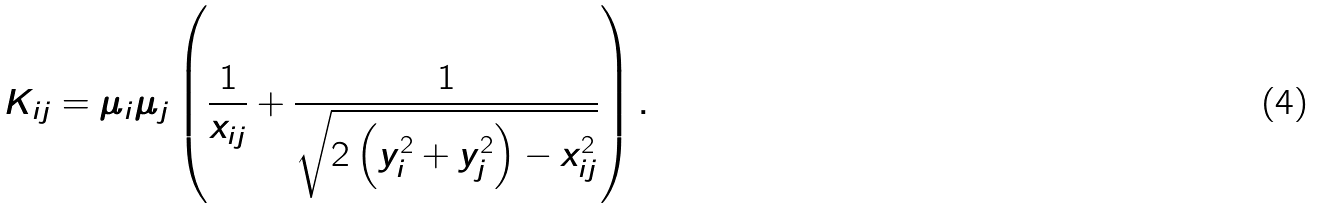<formula> <loc_0><loc_0><loc_500><loc_500>K _ { i j } = \mu _ { i } \mu _ { j } \left ( \frac { 1 } { x _ { i j } } + \frac { 1 } { \sqrt { 2 \left ( y _ { i } ^ { 2 } + y _ { j } ^ { 2 } \right ) - x _ { i j } ^ { 2 } } } \right ) .</formula> 